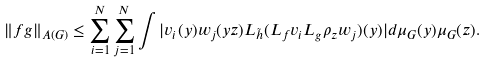<formula> <loc_0><loc_0><loc_500><loc_500>\| f g \| _ { A ( G ) } \leq \sum _ { i = 1 } ^ { N } { \sum _ { j = 1 } ^ { N } { \int { | v _ { i } ( y ) w _ { j } ( y z ) L _ { \tilde { h } } ( L _ { f } v _ { i } L _ { g } \rho _ { z } w _ { j } ) ( y ) | d \mu _ { G } ( y ) \mu _ { G } ( z ) } } } .</formula> 